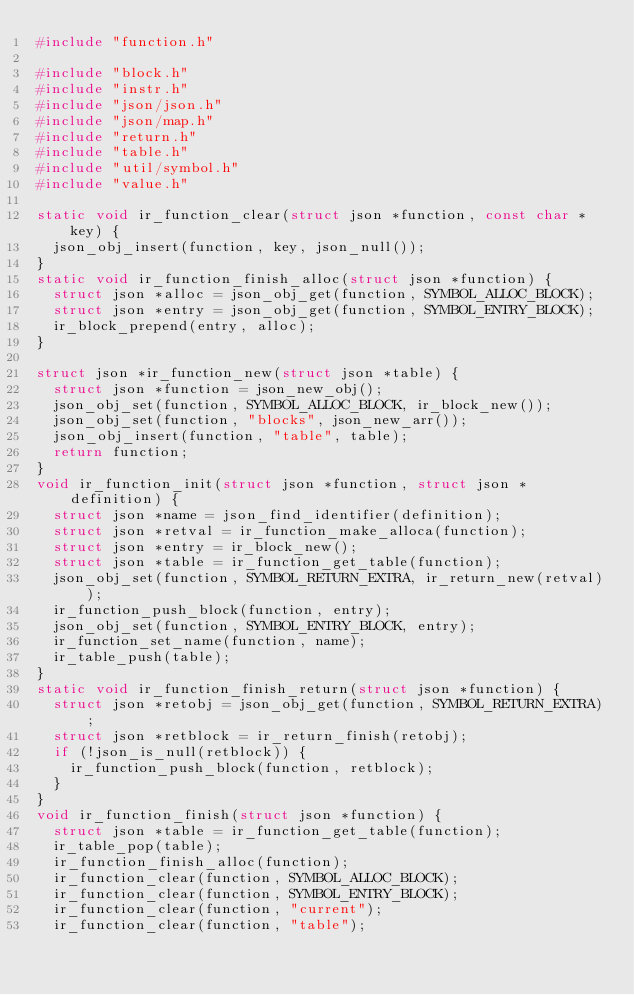Convert code to text. <code><loc_0><loc_0><loc_500><loc_500><_C_>#include "function.h"

#include "block.h"
#include "instr.h"
#include "json/json.h"
#include "json/map.h"
#include "return.h"
#include "table.h"
#include "util/symbol.h"
#include "value.h"

static void ir_function_clear(struct json *function, const char *key) {
  json_obj_insert(function, key, json_null());
}
static void ir_function_finish_alloc(struct json *function) {
  struct json *alloc = json_obj_get(function, SYMBOL_ALLOC_BLOCK);
  struct json *entry = json_obj_get(function, SYMBOL_ENTRY_BLOCK);
  ir_block_prepend(entry, alloc);
}

struct json *ir_function_new(struct json *table) {
  struct json *function = json_new_obj();
  json_obj_set(function, SYMBOL_ALLOC_BLOCK, ir_block_new());
  json_obj_set(function, "blocks", json_new_arr());
  json_obj_insert(function, "table", table);
  return function;
}
void ir_function_init(struct json *function, struct json *definition) {
  struct json *name = json_find_identifier(definition);
  struct json *retval = ir_function_make_alloca(function);
  struct json *entry = ir_block_new();
  struct json *table = ir_function_get_table(function);
  json_obj_set(function, SYMBOL_RETURN_EXTRA, ir_return_new(retval));
  ir_function_push_block(function, entry);
  json_obj_set(function, SYMBOL_ENTRY_BLOCK, entry);
  ir_function_set_name(function, name);
  ir_table_push(table);
}
static void ir_function_finish_return(struct json *function) {
  struct json *retobj = json_obj_get(function, SYMBOL_RETURN_EXTRA);
  struct json *retblock = ir_return_finish(retobj);
  if (!json_is_null(retblock)) {
    ir_function_push_block(function, retblock);
  }
}
void ir_function_finish(struct json *function) {
  struct json *table = ir_function_get_table(function);
  ir_table_pop(table);
  ir_function_finish_alloc(function);
  ir_function_clear(function, SYMBOL_ALLOC_BLOCK);
  ir_function_clear(function, SYMBOL_ENTRY_BLOCK);
  ir_function_clear(function, "current");
  ir_function_clear(function, "table");</code> 